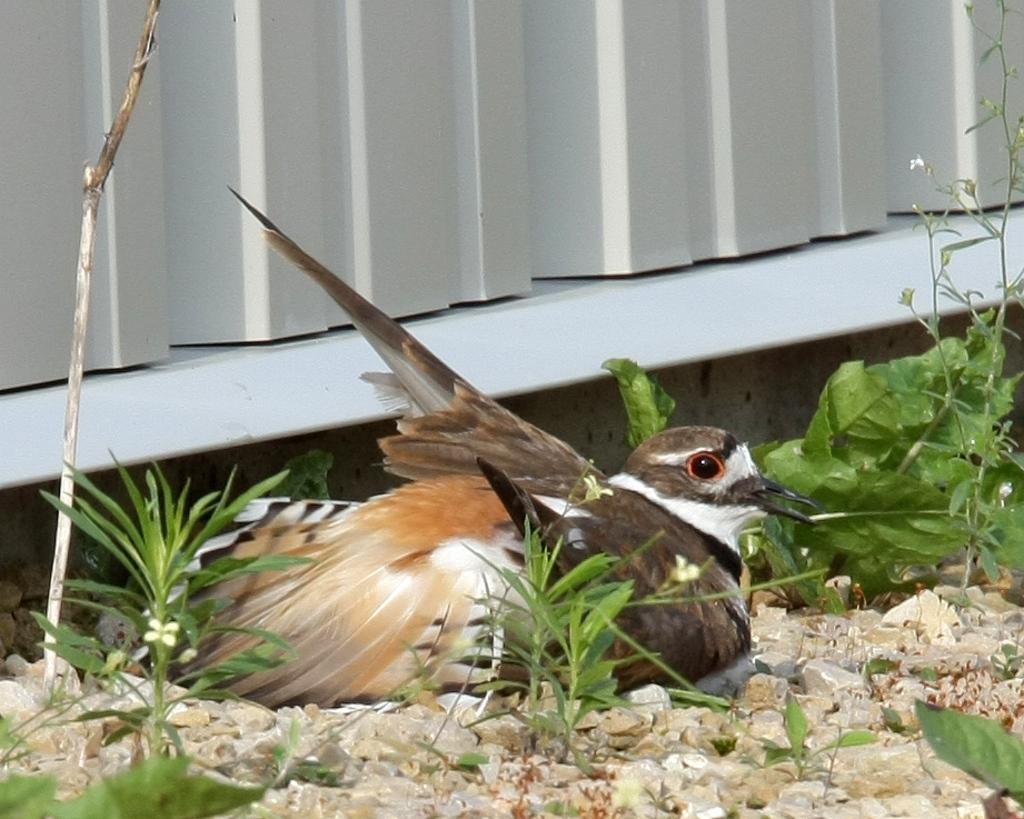Please provide a concise description of this image. In this image I can see the bird which is in white, brown and black color. It is on the stones. I can see the plants. I can see the white and ash color background. 